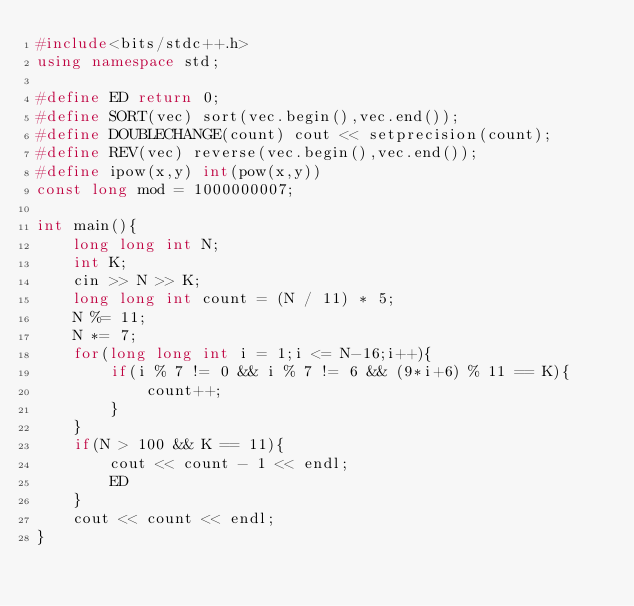Convert code to text. <code><loc_0><loc_0><loc_500><loc_500><_C++_>#include<bits/stdc++.h>
using namespace std;

#define ED return 0;
#define SORT(vec) sort(vec.begin(),vec.end());
#define DOUBLECHANGE(count) cout << setprecision(count);
#define REV(vec) reverse(vec.begin(),vec.end());
#define ipow(x,y) int(pow(x,y))
const long mod = 1000000007;

int main(){
    long long int N;
    int K;
    cin >> N >> K;
    long long int count = (N / 11) * 5;
    N %= 11;
    N *= 7;
    for(long long int i = 1;i <= N-16;i++){
        if(i % 7 != 0 && i % 7 != 6 && (9*i+6) % 11 == K){
            count++;
        }
    }
    if(N > 100 && K == 11){
        cout << count - 1 << endl;
        ED
    }
    cout << count << endl;
}
</code> 